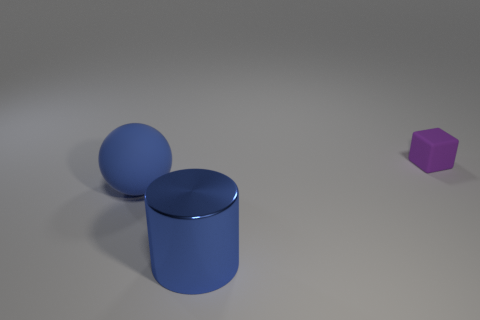Subtract all cylinders. How many objects are left? 2 Subtract 1 spheres. How many spheres are left? 0 Add 3 blue matte things. How many blue matte things are left? 4 Add 3 tiny cyan balls. How many tiny cyan balls exist? 3 Add 3 blue metal cylinders. How many objects exist? 6 Subtract 0 green spheres. How many objects are left? 3 Subtract all cyan blocks. Subtract all yellow cylinders. How many blocks are left? 1 Subtract all metal objects. Subtract all large blue matte spheres. How many objects are left? 1 